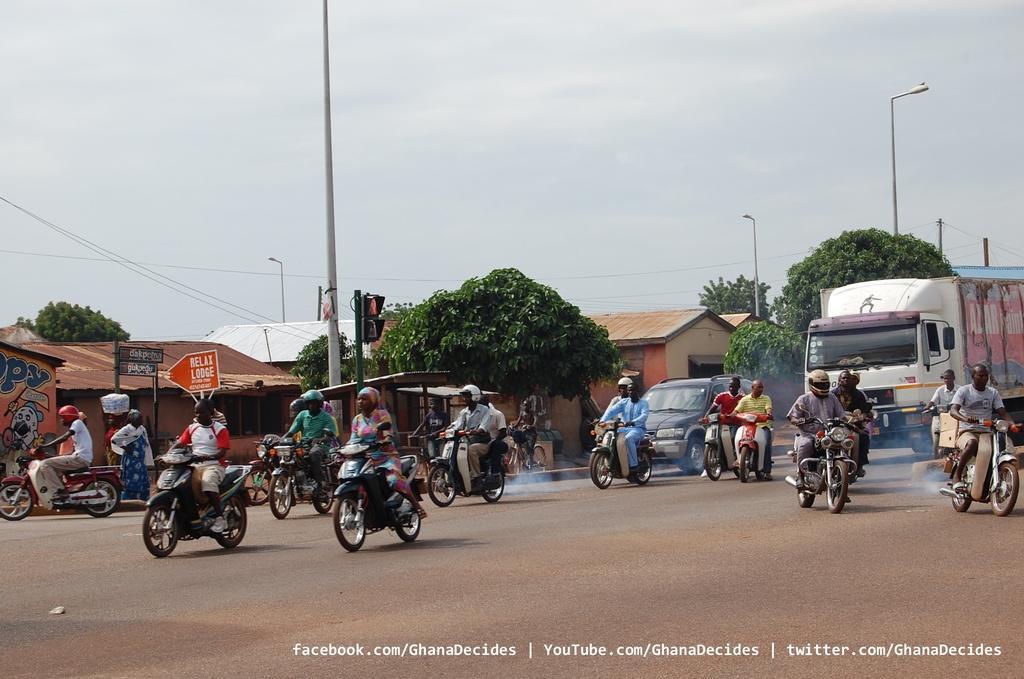Could you give a brief overview of what you see in this image? In this picture I can see group of people riding the motor bikes, there are vehicles on the road, there are houses, trees, boards, poles, lights, and in the background there is sky and there is a watermark on the image. 